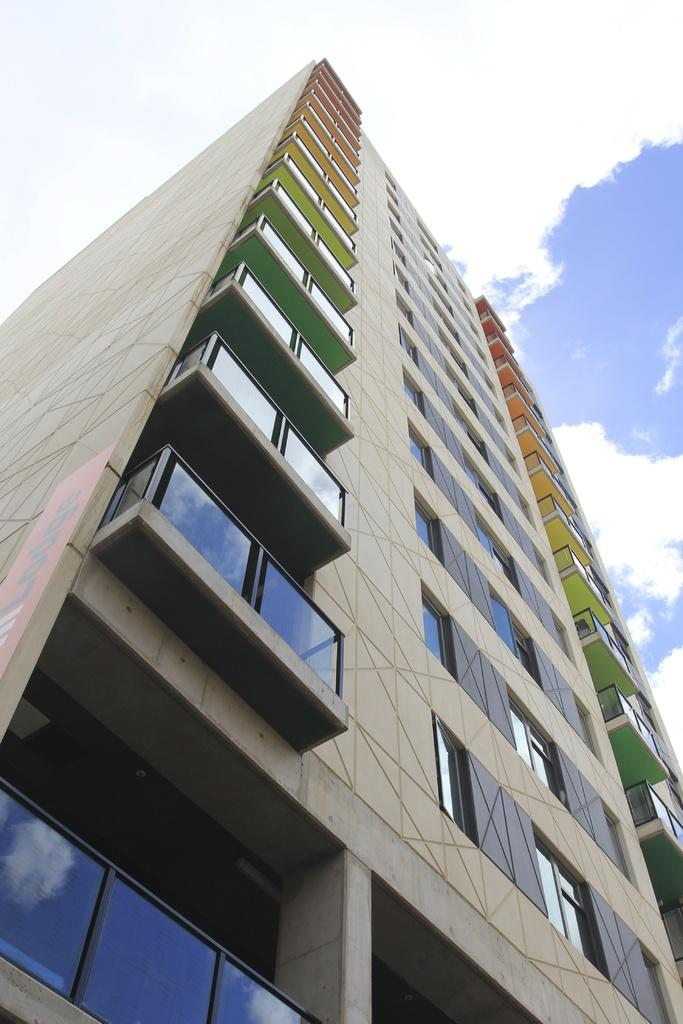What type of structure is present in the image? There is a building in the image. What feature can be observed on the building? The building has glass windows. What is visible in the sky in the image? The sky is clouded in the image. Can you tell me how many times the sun waves at the building in the image? The image does not show the sun waving at the building, and the sun is not visible in the image. How does the building run in the image? Buildings do not run; they are stationary structures. 